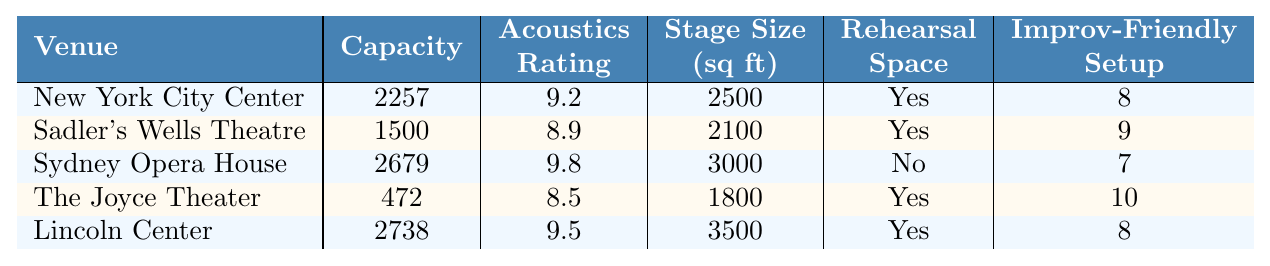What is the capacity of the Sydney Opera House? The table lists the Sydney Opera House with a capacity of 2679.
Answer: 2679 How many venues have a rehearsal space available? By looking at the table, four venues (New York City Center, Sadler's Wells Theatre, The Joyce Theater, Lincoln Center) have rehearsal space available, while Sydney Opera House does not.
Answer: 4 Which venue has the highest acoustics rating and what is that rating? The Sydney Opera House has the highest acoustics rating of 9.8 according to the table.
Answer: 9.8 What is the total capacity of all venues listed? Adding the capacities together: 2257 + 1500 + 2679 + 472 + 2738 = 11646.
Answer: 11646 How many venues have an improvisation-friendly setup with a score lower than 9? The only venue with a score lower than 9 that has an improvisation-friendly setup is The Joyce Theater, making it one venue.
Answer: 1 What is the average stage size across all venues? The average stage size is calculated by adding the stage sizes: (2500 + 2100 + 3000 + 1800 + 3500) = 14900 and dividing by the number of venues, which is 5: 14900 / 5 = 2980.
Answer: 2980 Which venue has the lowest capacity and how does it compare to the highest capacity venue? The Joyce Theater has the lowest capacity at 472, while Lincoln Center has the highest at 2738. The difference in capacity is 2738 - 472 = 2266.
Answer: 2266 Is there any venue with both rehearsal space available and the highest acoustics rating? No venue has both features; Sydney Opera House has the highest acoustics rating, but it does not have rehearsal space available.
Answer: No What are the stage sizes for venues that have an improvisation-friendly setup? The stage sizes for venues with an improvisation-friendly setup are: New York City Center (2500), Sadler's Wells Theatre (2100), The Joyce Theater (1800), and Lincoln Center (3500).
Answer: 2500, 2100, 1800, 3500 